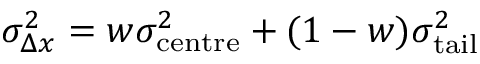<formula> <loc_0><loc_0><loc_500><loc_500>\sigma _ { \Delta x } ^ { 2 } = w \sigma _ { c e n t r e } ^ { 2 } + ( 1 - w ) \sigma _ { t a i l } ^ { 2 }</formula> 